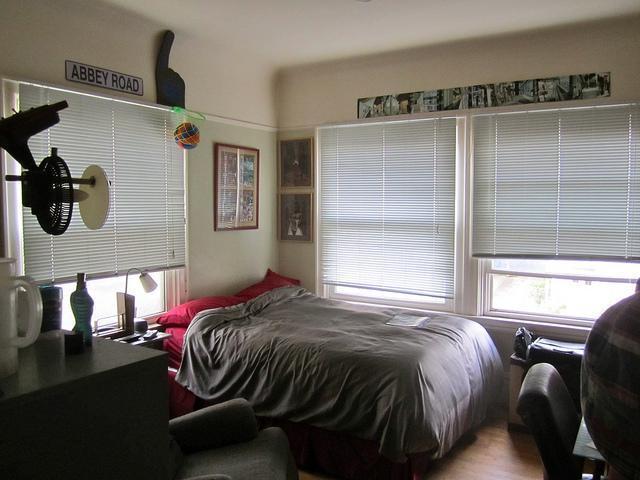How many boats are there?
Give a very brief answer. 0. 